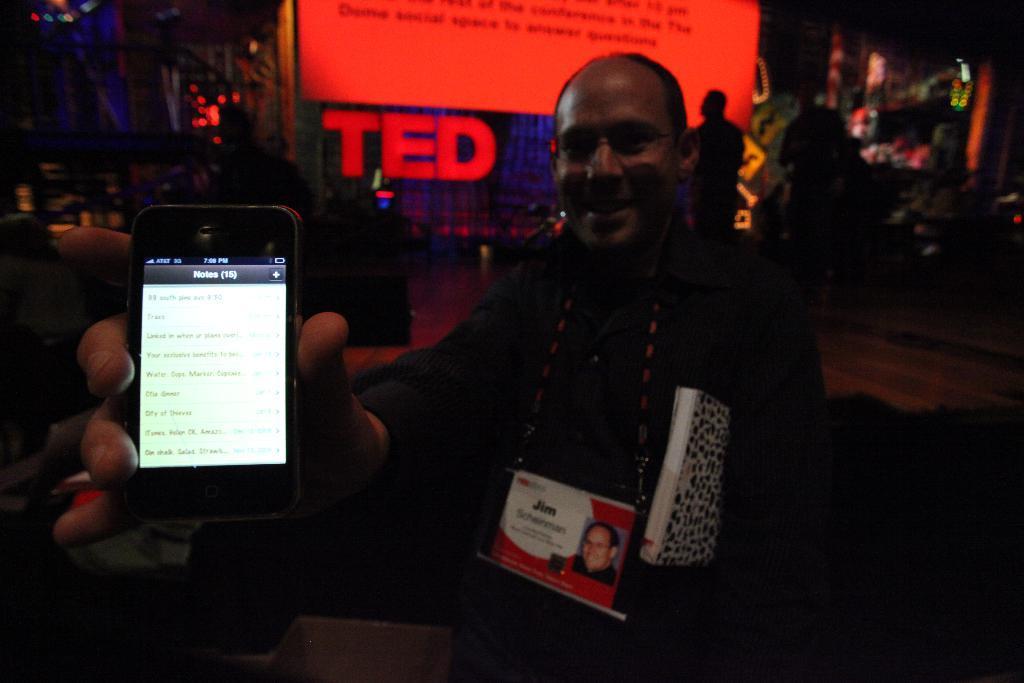Could you give a brief overview of what you see in this image? In the center of the image there is a person holding a phone. In the background of the image there are people. There is a banner. 